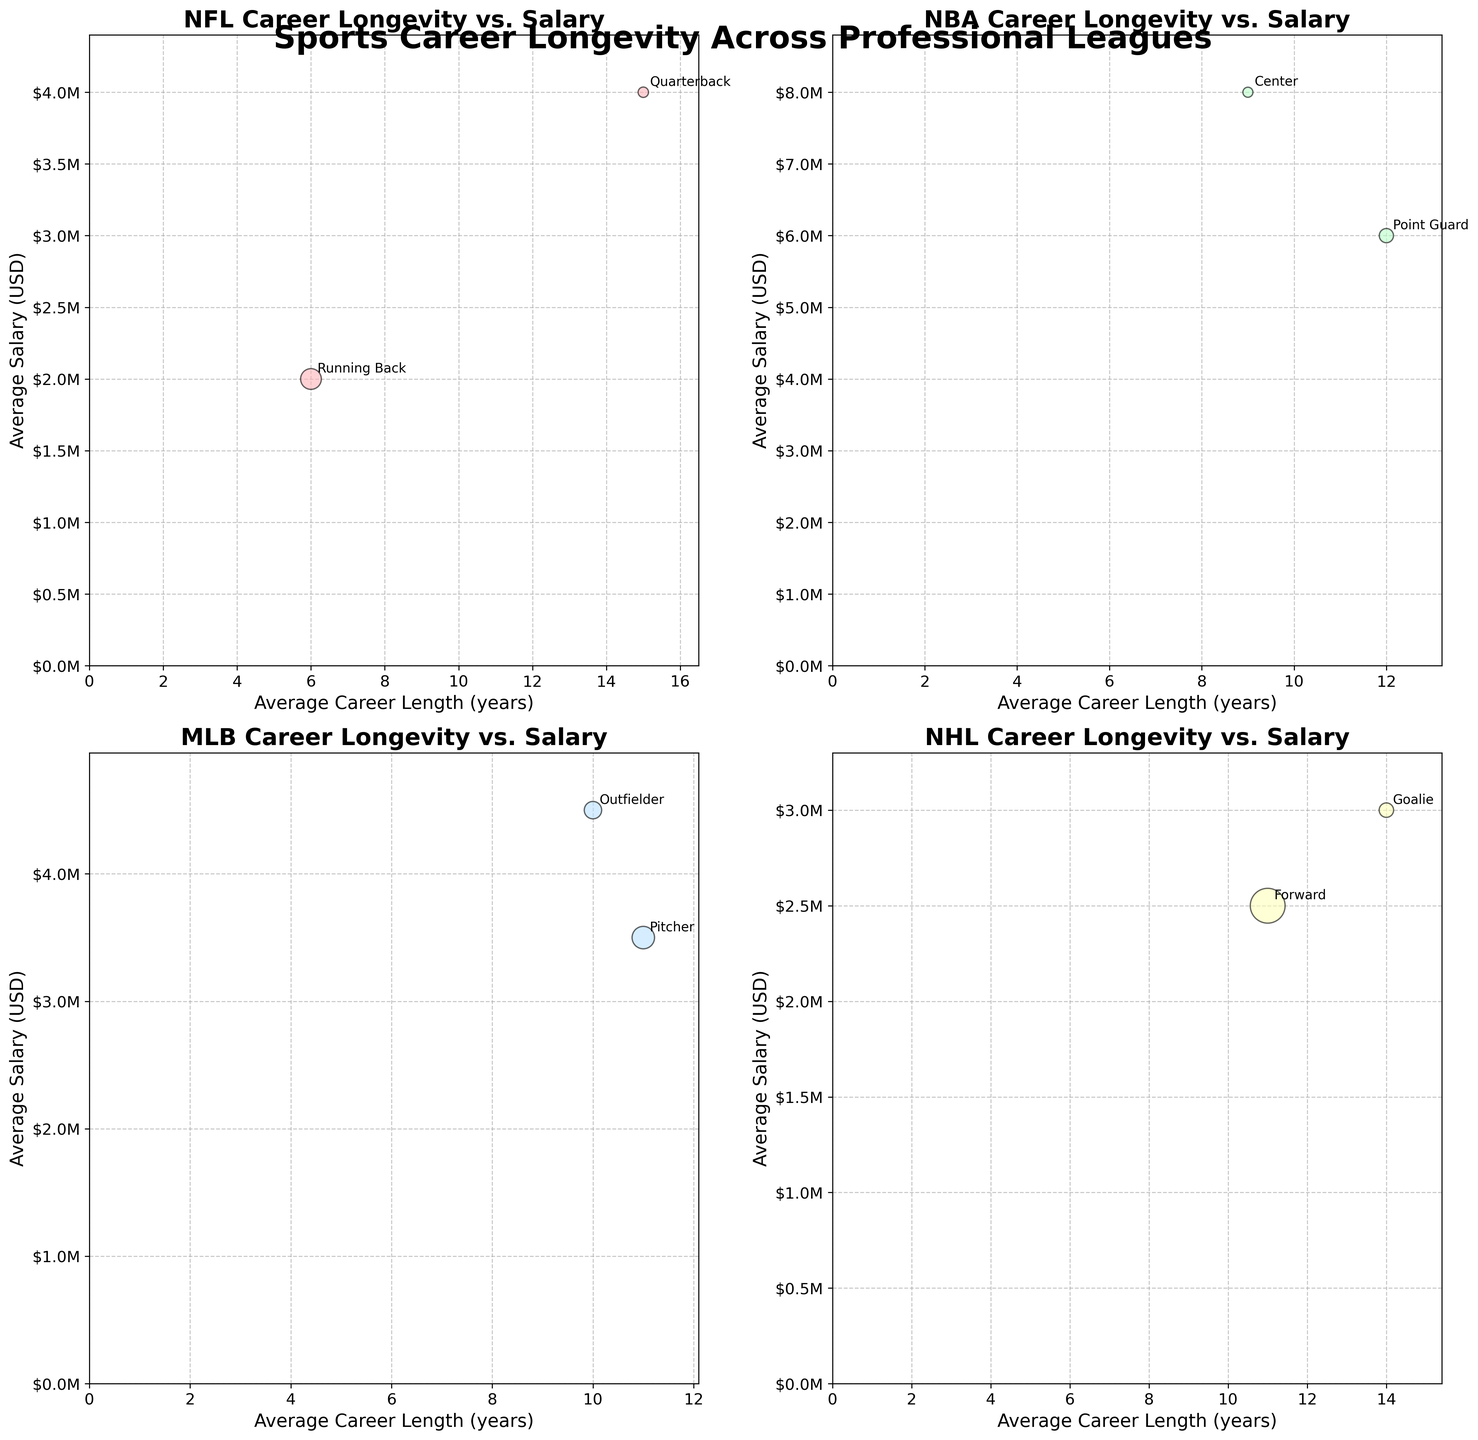What is the title of the figure? The title is written at the top of the plot in a bold and large font. It helps understand the main focus of the figure.
Answer: Sports Career Longevity Across Professional Leagues What does the y-axis represent in this figure? Along the y-axis, the figure labels the vertical dimension with a descriptor and units. This axis marks the average salary in USD.
Answer: Average Salary (USD) Which position in the NFL has the longest average career length? By looking at the NFL subplot, each position's average career length is represented along the x-axis. The position with the highest value on the x-axis has the longest career.
Answer: Quarterback Compare the average career length of Point Guards in the NBA and Goalies in the NHL. Which one is longer? Locate the average career length of both Point Guards from the NBA subplot and Goalies from the NHL subplot. Compare their respective x-axis values.
Answer: Point Guards in the NBA Which league shows the highest average salary for any position and what is that salary? Identify the highest y-axis value among all subplots that represent average salaries. Check which league subplot contains this maximum value.
Answer: NBA, approximately $8M Which position in the MLB has the larger number of players: Pitchers or Outfielders? Examine the MLB subplot and compare the bubble sizes for Pitchers and Outfielders, the larger bubble denotes a higher number of players.
Answer: Pitchers For Premier League Defenders and Strikers, which position has a higher average career length, and by how many years? In the Premier League subplot, locate Defenders and Strikers on the x-axis and compare their values. Compute the difference between these values.
Answer: Strikers, by 1 year What is the common trend between career length and average salary across the four main leagues (NFL, NBA, MLB, NHL)? Observe the relation patterns between x-axis (career length) and y-axis (salary) across all subplots to identify any visible trend.
Answer: Longer career lengths generally correspond to higher salaries By how much does the average salary for Quarterbacks in the NFL differ from that of Running Backs in the NFL? Check the y-axis values for Quarterbacks and Running Backs in the NFL subplot. Subtract the smaller value from the larger value.
Answer: $2,000,000 What is the typical shape of the bubbles and how are their sizes determined in the figure? Observe the figure's appearance, focusing on the shape of the bubbles and relating them to the number of players data provided.
Answer: Circular, proportional to the number of players 